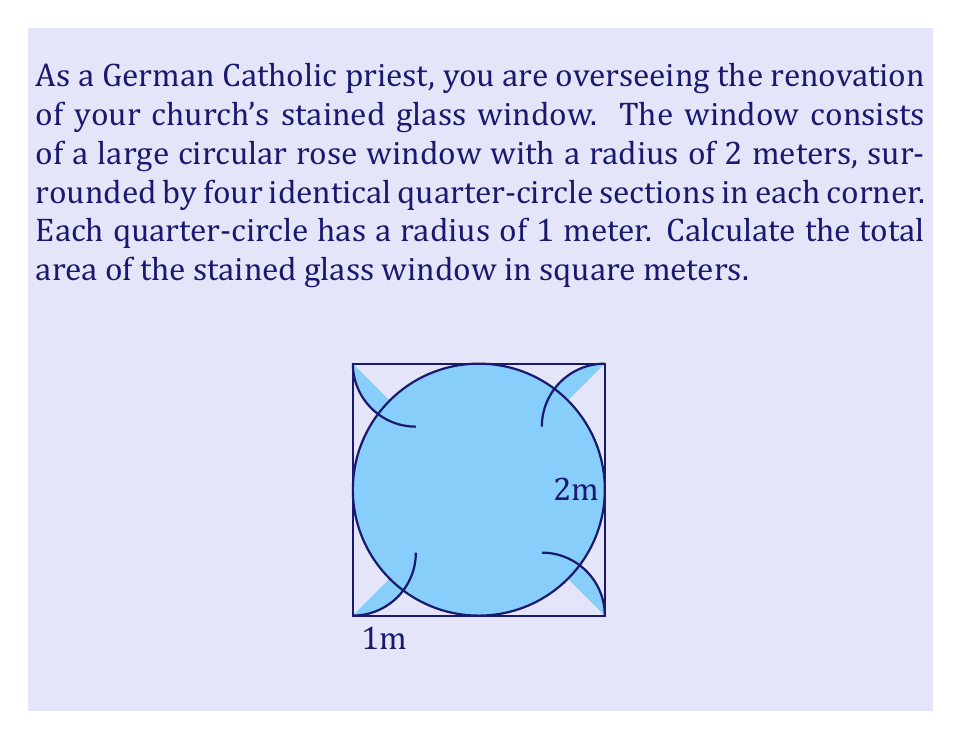Provide a solution to this math problem. To solve this problem, we need to calculate the areas of the circular rose window and the four quarter-circle sections, then sum them up.

1. Area of the circular rose window:
   The formula for the area of a circle is $A = \pi r^2$
   $$A_{rose} = \pi (2m)^2 = 4\pi m^2$$

2. Area of one quarter-circle section:
   The area of a quarter-circle is one-fourth of the area of a full circle
   $$A_{quarter} = \frac{1}{4} \pi r^2 = \frac{1}{4} \pi (1m)^2 = \frac{1}{4} \pi m^2$$

3. Total area of four quarter-circle sections:
   $$A_{corners} = 4 \cdot \frac{1}{4} \pi m^2 = \pi m^2$$

4. Total area of the stained glass window:
   $$\begin{align*}
   A_{total} &= A_{rose} + A_{corners} \\
   &= 4\pi m^2 + \pi m^2 \\
   &= 5\pi m^2
   \end{align*}$$

Therefore, the total area of the stained glass window is $5\pi$ square meters.
Answer: $5\pi$ square meters (approximately 15.71 square meters) 